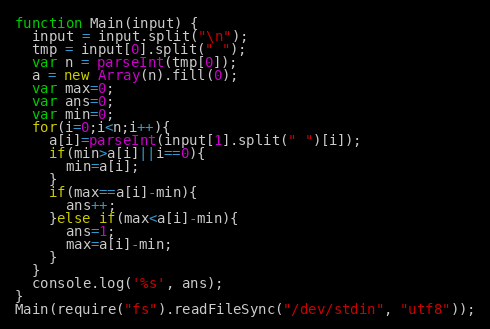Convert code to text. <code><loc_0><loc_0><loc_500><loc_500><_JavaScript_>function Main(input) {
  input = input.split("\n");
  tmp = input[0].split(" ");
  var n = parseInt(tmp[0]);
  a = new Array(n).fill(0);
  var max=0;
  var ans=0;
  var min=0;
  for(i=0;i<n;i++){
    a[i]=parseInt(input[1].split(" ")[i]);
    if(min>a[i]||i==0){
      min=a[i];
    }
    if(max==a[i]-min){
      ans++;
    }else if(max<a[i]-min){
      ans=1;
      max=a[i]-min;
    }
  }
  console.log('%s', ans);
}
Main(require("fs").readFileSync("/dev/stdin", "utf8"));</code> 